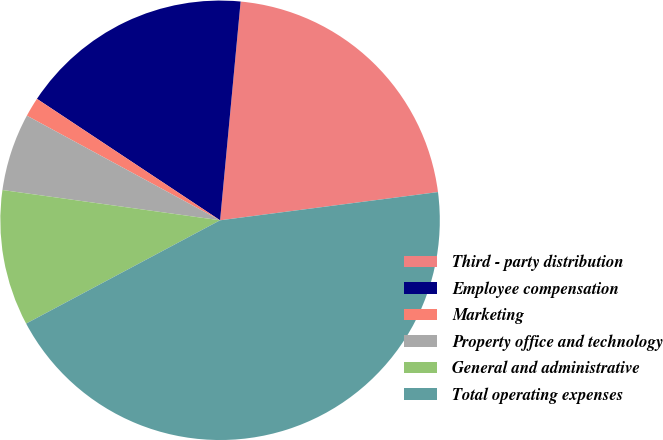Convert chart. <chart><loc_0><loc_0><loc_500><loc_500><pie_chart><fcel>Third - party distribution<fcel>Employee compensation<fcel>Marketing<fcel>Property office and technology<fcel>General and administrative<fcel>Total operating expenses<nl><fcel>21.46%<fcel>17.17%<fcel>1.42%<fcel>5.7%<fcel>9.99%<fcel>44.26%<nl></chart> 